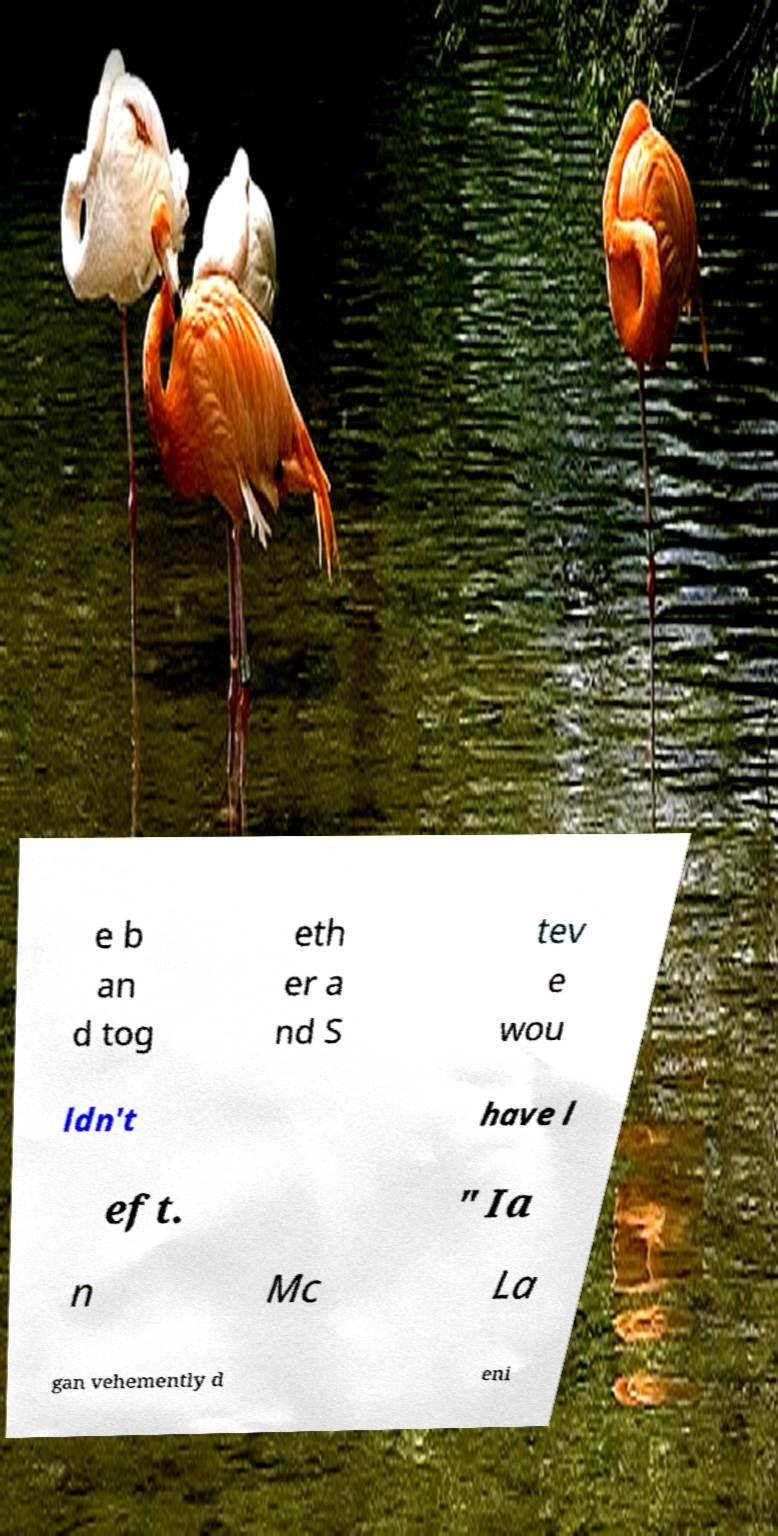For documentation purposes, I need the text within this image transcribed. Could you provide that? e b an d tog eth er a nd S tev e wou ldn't have l eft. " Ia n Mc La gan vehemently d eni 